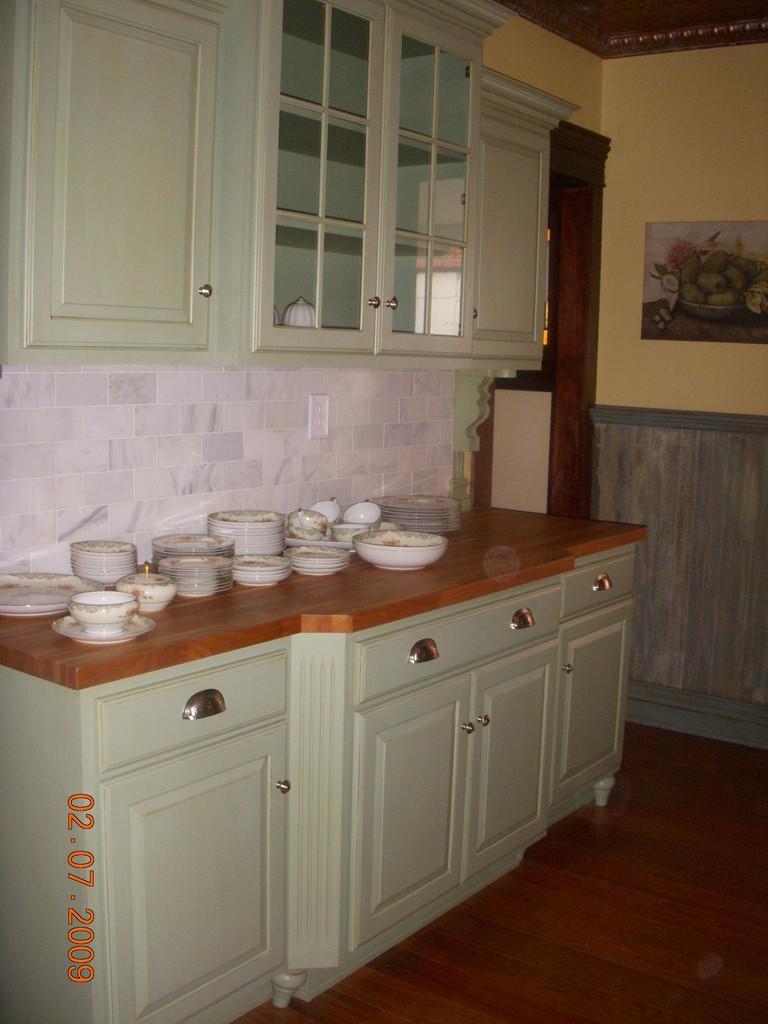Please provide a concise description of this image. In this image I can see a kitchen cabinet on which plates, bowls are kept. In the background I can see a wall painting, window and a rooftop. This image is taken may be in a room. 